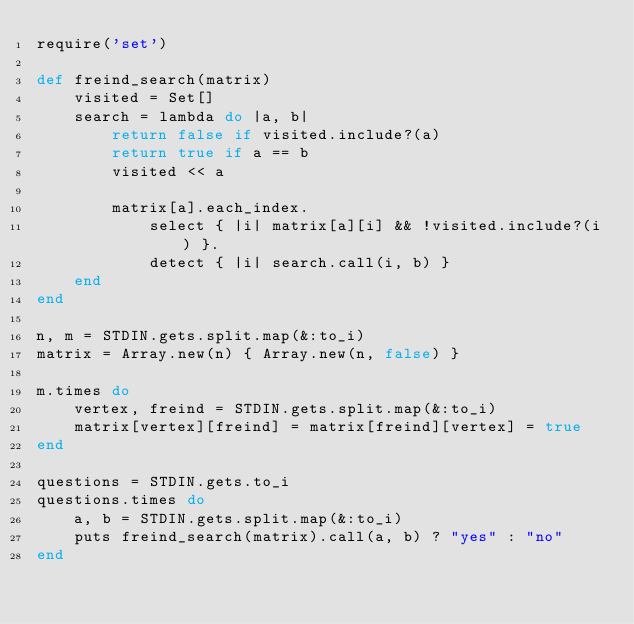Convert code to text. <code><loc_0><loc_0><loc_500><loc_500><_Ruby_>require('set')

def freind_search(matrix)
	visited = Set[]
	search = lambda do |a, b|
		return false if visited.include?(a)
		return true if a == b
		visited << a

		matrix[a].each_index.
			select { |i| matrix[a][i] && !visited.include?(i) }.
			detect { |i| search.call(i, b) }
	end
end

n, m = STDIN.gets.split.map(&:to_i)
matrix = Array.new(n) { Array.new(n, false) }

m.times do
	vertex, freind = STDIN.gets.split.map(&:to_i)
	matrix[vertex][freind] = matrix[freind][vertex] = true
end

questions = STDIN.gets.to_i
questions.times do
	a, b = STDIN.gets.split.map(&:to_i)
	puts freind_search(matrix).call(a, b) ? "yes" : "no"
end</code> 